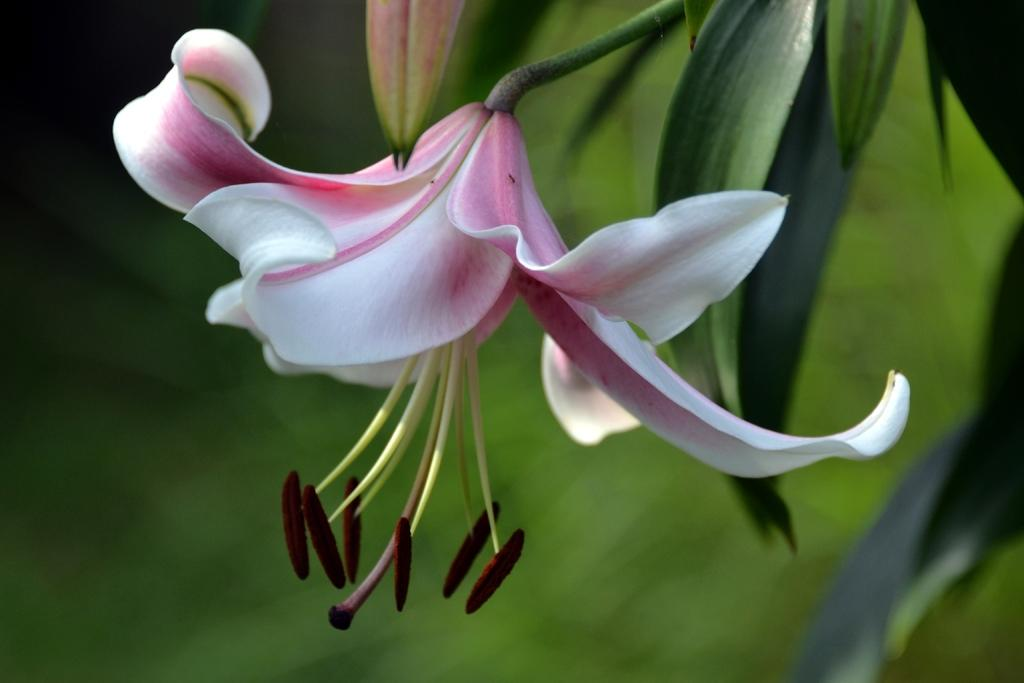What is the main subject in the center of the image? There is a flower in the center of the image. Can you describe the flower's surroundings? The flower is part of a plant. What type of window can be seen in the image? There is no window present in the image; it features a flower in the center of the image. 